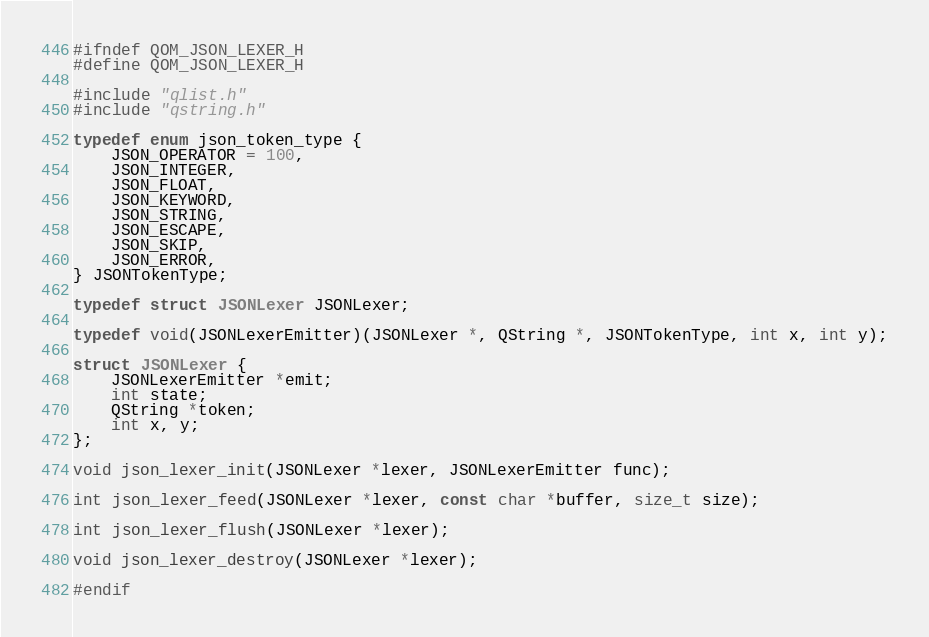Convert code to text. <code><loc_0><loc_0><loc_500><loc_500><_C_>
#ifndef QOM_JSON_LEXER_H
#define QOM_JSON_LEXER_H

#include "qlist.h"
#include "qstring.h"

typedef enum json_token_type {
    JSON_OPERATOR = 100,
    JSON_INTEGER,
    JSON_FLOAT,
    JSON_KEYWORD,
    JSON_STRING,
    JSON_ESCAPE,
    JSON_SKIP,
    JSON_ERROR,
} JSONTokenType;

typedef struct JSONLexer JSONLexer;

typedef void(JSONLexerEmitter)(JSONLexer *, QString *, JSONTokenType, int x, int y);

struct JSONLexer {
    JSONLexerEmitter *emit;
    int state;
    QString *token;
    int x, y;
};

void json_lexer_init(JSONLexer *lexer, JSONLexerEmitter func);

int json_lexer_feed(JSONLexer *lexer, const char *buffer, size_t size);

int json_lexer_flush(JSONLexer *lexer);

void json_lexer_destroy(JSONLexer *lexer);

#endif
</code> 